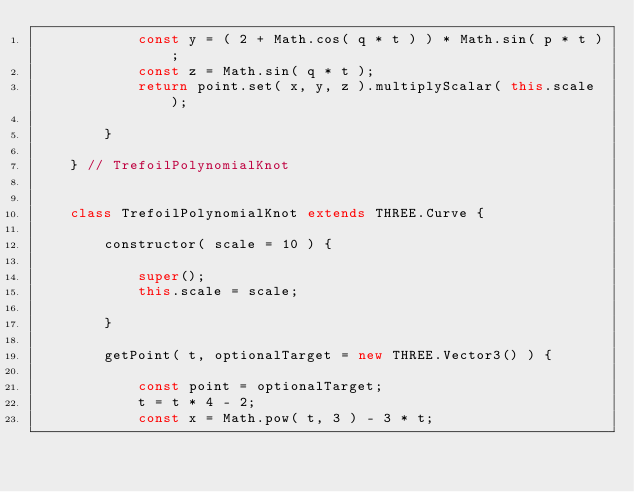<code> <loc_0><loc_0><loc_500><loc_500><_JavaScript_>			const y = ( 2 + Math.cos( q * t ) ) * Math.sin( p * t );
			const z = Math.sin( q * t );
			return point.set( x, y, z ).multiplyScalar( this.scale );

		}

	} // TrefoilPolynomialKnot


	class TrefoilPolynomialKnot extends THREE.Curve {

		constructor( scale = 10 ) {

			super();
			this.scale = scale;

		}

		getPoint( t, optionalTarget = new THREE.Vector3() ) {

			const point = optionalTarget;
			t = t * 4 - 2;
			const x = Math.pow( t, 3 ) - 3 * t;</code> 